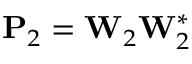Convert formula to latex. <formula><loc_0><loc_0><loc_500><loc_500>P _ { 2 } = W _ { 2 } W _ { 2 } ^ { * }</formula> 